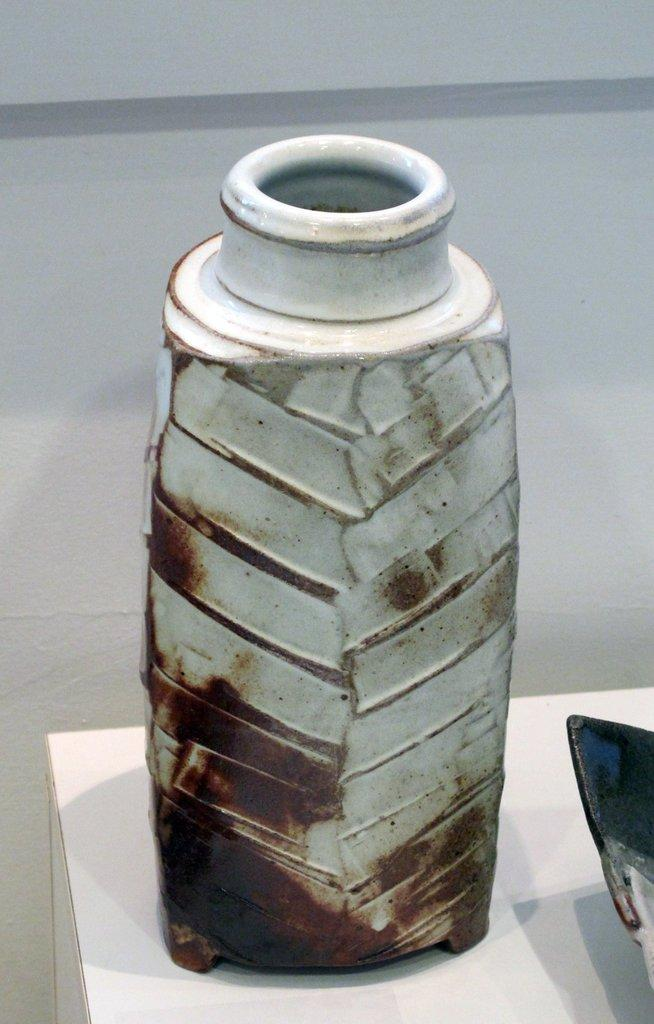What type of object is in the image? There is a ceramic bottle in the image. Where is the ceramic bottle located? The ceramic bottle is kept on a table. What type of animals can be seen at the zoo in the image? There is no zoo present in the image; it features a ceramic bottle on a table. What type of doll is holding the ceramic bottle in the image? There is no doll present in the image; it only features a ceramic bottle on a table. 